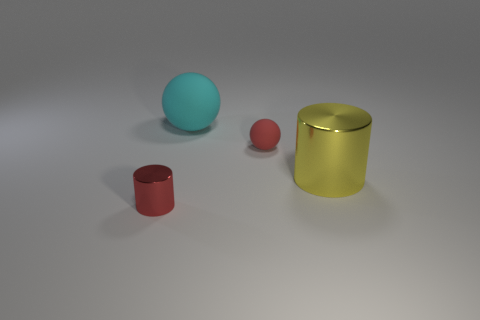Do the small metal object and the cylinder on the right side of the small ball have the same color?
Provide a short and direct response. No. How many tiny red metal cylinders are to the left of the cyan ball?
Give a very brief answer. 1. Are there fewer yellow rubber blocks than big cylinders?
Offer a very short reply. Yes. How big is the thing that is both on the left side of the tiny matte object and on the right side of the small cylinder?
Make the answer very short. Large. There is a tiny object on the left side of the cyan matte sphere; does it have the same color as the tiny matte ball?
Your answer should be compact. Yes. Are there fewer cylinders that are on the right side of the big cyan rubber object than big cubes?
Offer a very short reply. No. There is a object that is made of the same material as the yellow cylinder; what shape is it?
Make the answer very short. Cylinder. Does the yellow thing have the same material as the big cyan object?
Offer a very short reply. No. Are there fewer tiny cylinders that are behind the big sphere than large cylinders that are on the left side of the tiny red metallic cylinder?
Make the answer very short. No. There is a metal cylinder that is the same color as the tiny matte ball; what is its size?
Your response must be concise. Small. 